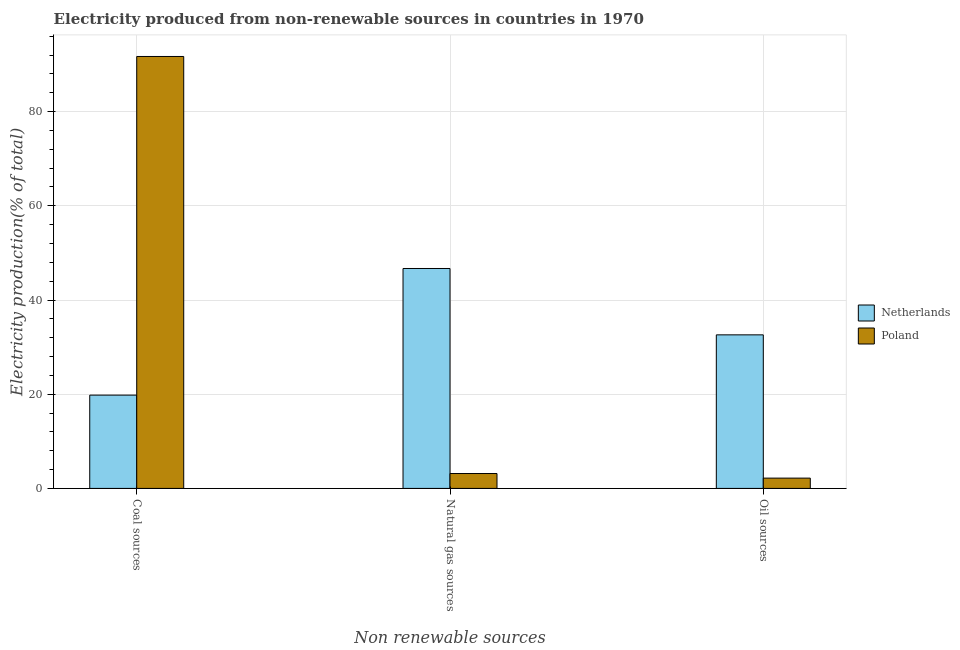How many different coloured bars are there?
Give a very brief answer. 2. What is the label of the 2nd group of bars from the left?
Your answer should be very brief. Natural gas sources. What is the percentage of electricity produced by oil sources in Poland?
Keep it short and to the point. 2.19. Across all countries, what is the maximum percentage of electricity produced by natural gas?
Keep it short and to the point. 46.69. Across all countries, what is the minimum percentage of electricity produced by natural gas?
Offer a very short reply. 3.16. In which country was the percentage of electricity produced by natural gas maximum?
Your answer should be very brief. Netherlands. What is the total percentage of electricity produced by oil sources in the graph?
Provide a short and direct response. 34.79. What is the difference between the percentage of electricity produced by natural gas in Poland and that in Netherlands?
Offer a terse response. -43.52. What is the difference between the percentage of electricity produced by coal in Poland and the percentage of electricity produced by natural gas in Netherlands?
Give a very brief answer. 45.01. What is the average percentage of electricity produced by natural gas per country?
Your answer should be compact. 24.93. What is the difference between the percentage of electricity produced by coal and percentage of electricity produced by natural gas in Poland?
Your response must be concise. 88.54. In how many countries, is the percentage of electricity produced by coal greater than 68 %?
Ensure brevity in your answer.  1. What is the ratio of the percentage of electricity produced by coal in Poland to that in Netherlands?
Provide a short and direct response. 4.63. What is the difference between the highest and the second highest percentage of electricity produced by oil sources?
Give a very brief answer. 30.42. What is the difference between the highest and the lowest percentage of electricity produced by natural gas?
Provide a short and direct response. 43.52. Is it the case that in every country, the sum of the percentage of electricity produced by coal and percentage of electricity produced by natural gas is greater than the percentage of electricity produced by oil sources?
Your answer should be compact. Yes. How many bars are there?
Offer a terse response. 6. Are all the bars in the graph horizontal?
Provide a short and direct response. No. What is the difference between two consecutive major ticks on the Y-axis?
Provide a succinct answer. 20. What is the title of the graph?
Your response must be concise. Electricity produced from non-renewable sources in countries in 1970. What is the label or title of the X-axis?
Provide a succinct answer. Non renewable sources. What is the label or title of the Y-axis?
Offer a very short reply. Electricity production(% of total). What is the Electricity production(% of total) in Netherlands in Coal sources?
Provide a short and direct response. 19.81. What is the Electricity production(% of total) in Poland in Coal sources?
Your answer should be compact. 91.7. What is the Electricity production(% of total) of Netherlands in Natural gas sources?
Provide a succinct answer. 46.69. What is the Electricity production(% of total) in Poland in Natural gas sources?
Make the answer very short. 3.16. What is the Electricity production(% of total) in Netherlands in Oil sources?
Your response must be concise. 32.6. What is the Electricity production(% of total) in Poland in Oil sources?
Your answer should be very brief. 2.19. Across all Non renewable sources, what is the maximum Electricity production(% of total) in Netherlands?
Give a very brief answer. 46.69. Across all Non renewable sources, what is the maximum Electricity production(% of total) in Poland?
Make the answer very short. 91.7. Across all Non renewable sources, what is the minimum Electricity production(% of total) of Netherlands?
Give a very brief answer. 19.81. Across all Non renewable sources, what is the minimum Electricity production(% of total) in Poland?
Ensure brevity in your answer.  2.19. What is the total Electricity production(% of total) of Netherlands in the graph?
Make the answer very short. 99.1. What is the total Electricity production(% of total) of Poland in the graph?
Make the answer very short. 97.05. What is the difference between the Electricity production(% of total) of Netherlands in Coal sources and that in Natural gas sources?
Your answer should be very brief. -26.88. What is the difference between the Electricity production(% of total) in Poland in Coal sources and that in Natural gas sources?
Offer a terse response. 88.54. What is the difference between the Electricity production(% of total) of Netherlands in Coal sources and that in Oil sources?
Your answer should be compact. -12.8. What is the difference between the Electricity production(% of total) of Poland in Coal sources and that in Oil sources?
Ensure brevity in your answer.  89.51. What is the difference between the Electricity production(% of total) in Netherlands in Natural gas sources and that in Oil sources?
Your answer should be very brief. 14.09. What is the difference between the Electricity production(% of total) of Poland in Natural gas sources and that in Oil sources?
Your response must be concise. 0.98. What is the difference between the Electricity production(% of total) of Netherlands in Coal sources and the Electricity production(% of total) of Poland in Natural gas sources?
Your answer should be compact. 16.64. What is the difference between the Electricity production(% of total) of Netherlands in Coal sources and the Electricity production(% of total) of Poland in Oil sources?
Ensure brevity in your answer.  17.62. What is the difference between the Electricity production(% of total) of Netherlands in Natural gas sources and the Electricity production(% of total) of Poland in Oil sources?
Your response must be concise. 44.5. What is the average Electricity production(% of total) in Netherlands per Non renewable sources?
Provide a succinct answer. 33.03. What is the average Electricity production(% of total) in Poland per Non renewable sources?
Your answer should be very brief. 32.35. What is the difference between the Electricity production(% of total) in Netherlands and Electricity production(% of total) in Poland in Coal sources?
Your response must be concise. -71.89. What is the difference between the Electricity production(% of total) of Netherlands and Electricity production(% of total) of Poland in Natural gas sources?
Provide a succinct answer. 43.52. What is the difference between the Electricity production(% of total) in Netherlands and Electricity production(% of total) in Poland in Oil sources?
Your response must be concise. 30.42. What is the ratio of the Electricity production(% of total) of Netherlands in Coal sources to that in Natural gas sources?
Ensure brevity in your answer.  0.42. What is the ratio of the Electricity production(% of total) in Poland in Coal sources to that in Natural gas sources?
Provide a succinct answer. 28.98. What is the ratio of the Electricity production(% of total) of Netherlands in Coal sources to that in Oil sources?
Offer a very short reply. 0.61. What is the ratio of the Electricity production(% of total) of Poland in Coal sources to that in Oil sources?
Give a very brief answer. 41.92. What is the ratio of the Electricity production(% of total) in Netherlands in Natural gas sources to that in Oil sources?
Your answer should be very brief. 1.43. What is the ratio of the Electricity production(% of total) in Poland in Natural gas sources to that in Oil sources?
Your answer should be very brief. 1.45. What is the difference between the highest and the second highest Electricity production(% of total) in Netherlands?
Provide a succinct answer. 14.09. What is the difference between the highest and the second highest Electricity production(% of total) of Poland?
Your answer should be compact. 88.54. What is the difference between the highest and the lowest Electricity production(% of total) of Netherlands?
Give a very brief answer. 26.88. What is the difference between the highest and the lowest Electricity production(% of total) in Poland?
Your answer should be very brief. 89.51. 